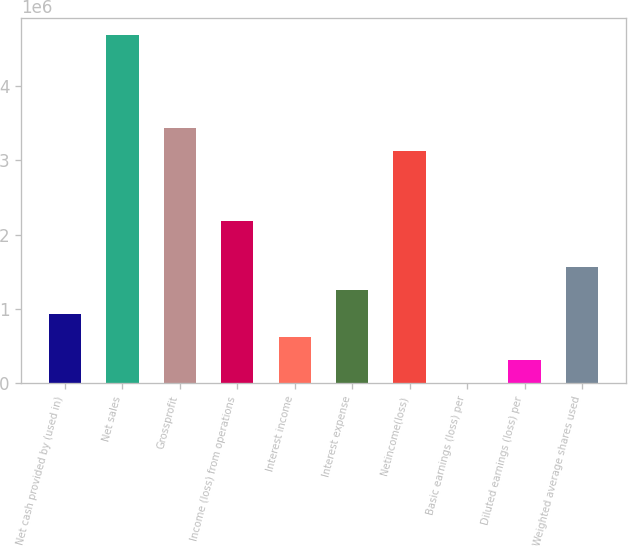Convert chart to OTSL. <chart><loc_0><loc_0><loc_500><loc_500><bar_chart><fcel>Net cash provided by (used in)<fcel>Net sales<fcel>Grossprofit<fcel>Income (loss) from operations<fcel>Interest income<fcel>Interest expense<fcel>Netincome(loss)<fcel>Basic earnings (loss) per<fcel>Diluted earnings (loss) per<fcel>Weighted average shares used<nl><fcel>936731<fcel>4.68365e+06<fcel>3.43468e+06<fcel>2.1857e+06<fcel>624488<fcel>1.24897e+06<fcel>3.12243e+06<fcel>1.56<fcel>312245<fcel>1.56122e+06<nl></chart> 